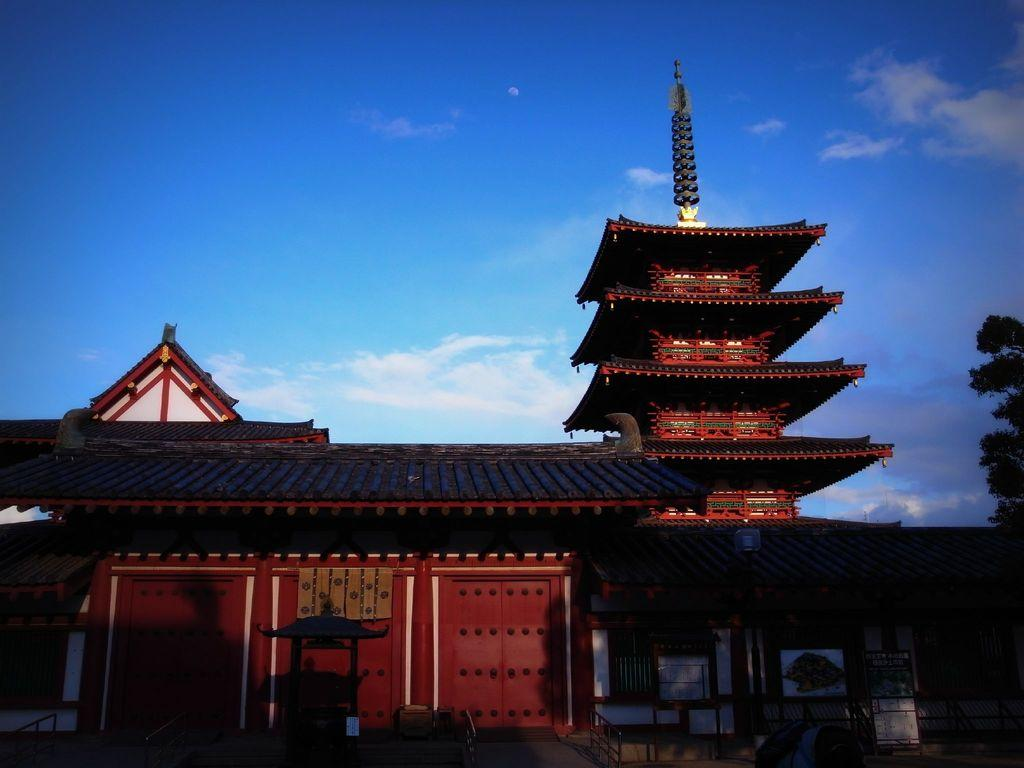What type of structure is visible in the image? There is a house in the image. What can be seen at the top of the house? There are unspecified things at the top of the house. What colors are the unspecified things at the top of the house? The unspecified things at the top are in red and black color. What type of vegetation is near the house? There is a tree to the side of the house. Can you tell me how many yaks are grazing near the tree in the image? There are no yaks present in the image; it only features a house, unspecified things at the top of the house, and a tree. 